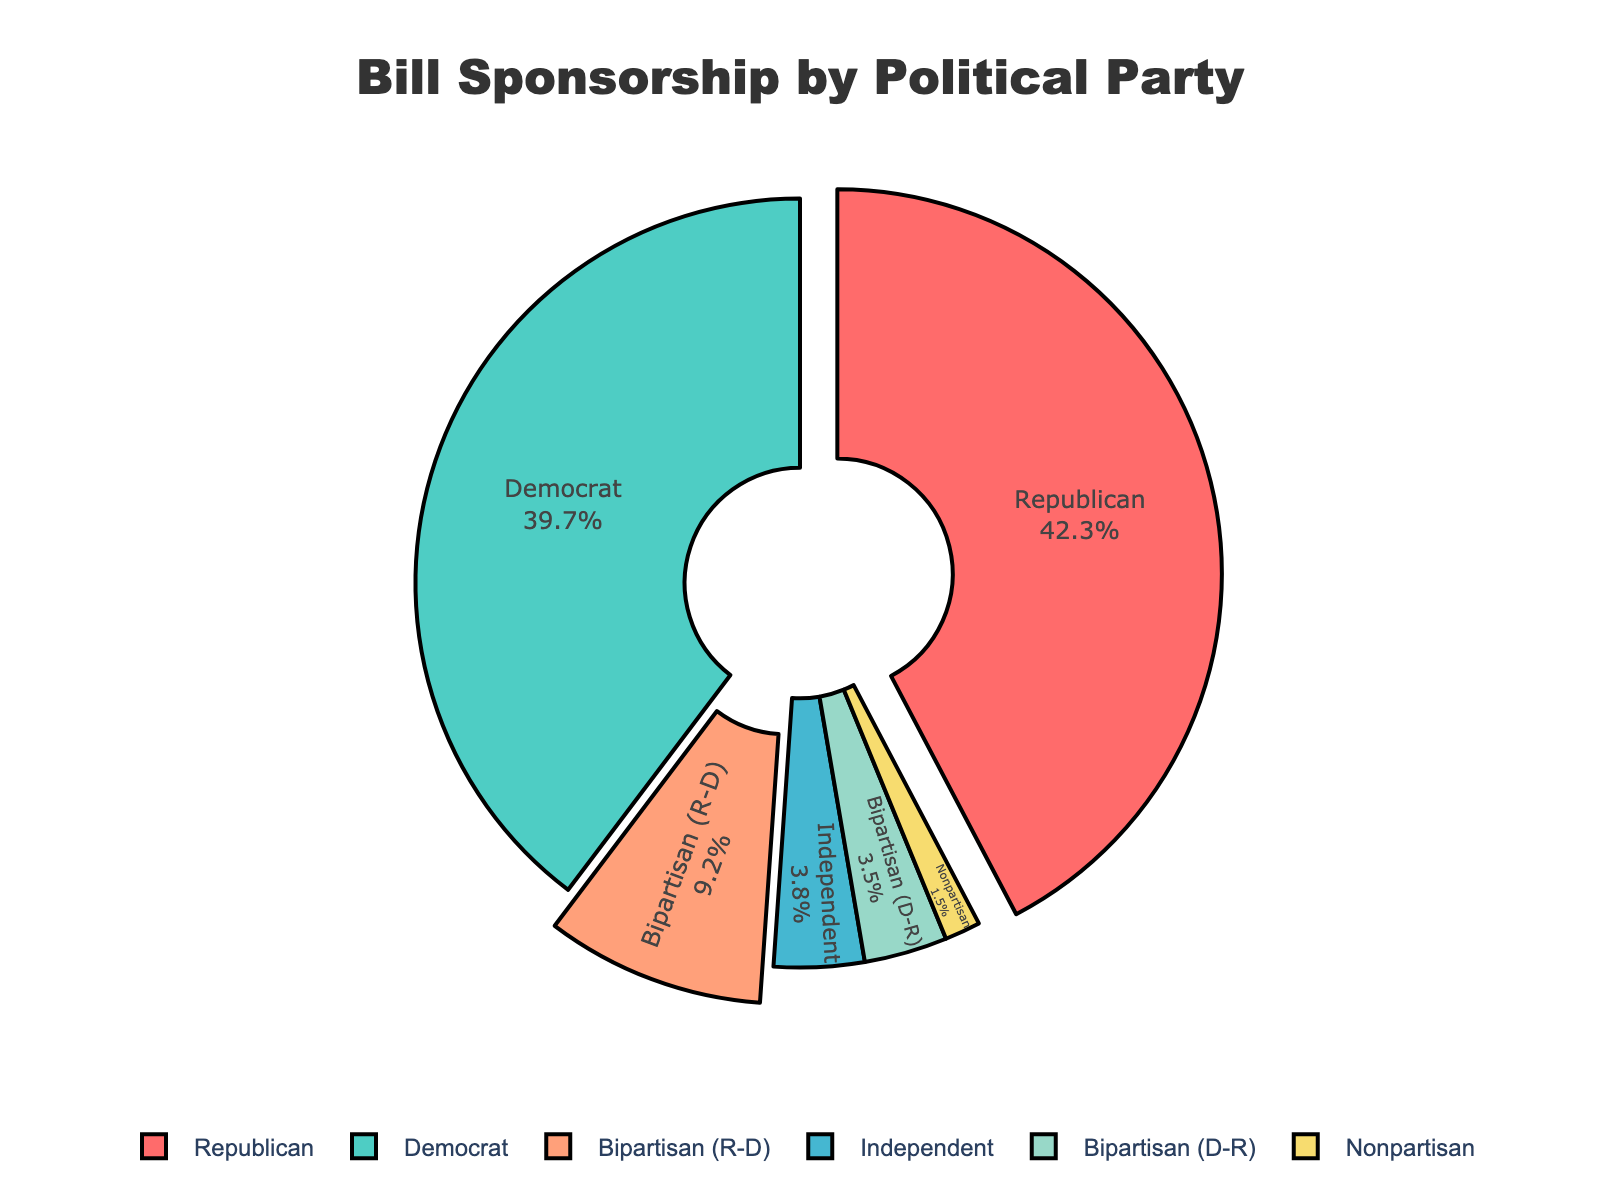What percentage of bills are sponsored by Democrats? Referring to the pie chart, look for the segment labeled "Democrat" and note the associated percentage value.
Answer: 39.7% Which party has the highest percentage of bill sponsorships? Compare the percentage values for each party shown in the pie chart and identify the highest value.
Answer: Republican How many more percentage points do Republicans have than Democrats in bill sponsorship? Subtract the percentage of Democrats from the percentage of Republicans: 42.3% - 39.7% = 2.6%
Answer: 2.6% What is the combined percentage of bills sponsored by Bipartisan (R-D) and Bipartisan (D-R)? Add the percentages for Bipartisan (R-D) and Bipartisan (D-R): 9.2% + 3.5% = 12.7%
Answer: 12.7% Is the percentage of bills sponsored by Nonpartisan higher, lower, or equal to that sponsored by Independents? Compare the percentage values of Nonpartisan (1.5%) and Independents (3.8%).
Answer: Lower Which segment in the pie chart is pulled out the most? Visually inspect the pie chart and identify the segment that appears to be pulled out or separated from the main pie: Republican and Bipartisan (R-D).
Answer: Republican and Bipartisan (R-D) How does the percentage of Bipartisan (R-D) sponsorship compare to that of Nonpartisan sponsorship? Compare the percentage values of Bipartisan (R-D) (9.2%) and Nonpartisan (1.5%).
Answer: Greater If you add the percentage of sponsorships by Independents and Nonpartisan groups, what is the result? Sum the percentages for Independents (3.8%) and Nonpartisan (1.5%): 3.8% + 1.5% = 5.3%.
Answer: 5.3% What is the approximate difference in bill sponsorship percentage between the party with the highest and the party with the lowest sponsorship? Subtract the lowest percentage (Nonpartisan, 1.5%) from the highest percentage (Republican, 42.3%): 42.3% - 1.5% = 40.8%.
Answer: 40.8% What is the total percentage of bills that are not solely sponsored by Republicans or Democrats? Add the percentages of Independents, Bipartisan (R-D), Bipartisan (D-R), and Nonpartisan: 3.8% + 9.2% + 3.5% + 1.5% = 18%.
Answer: 18% 